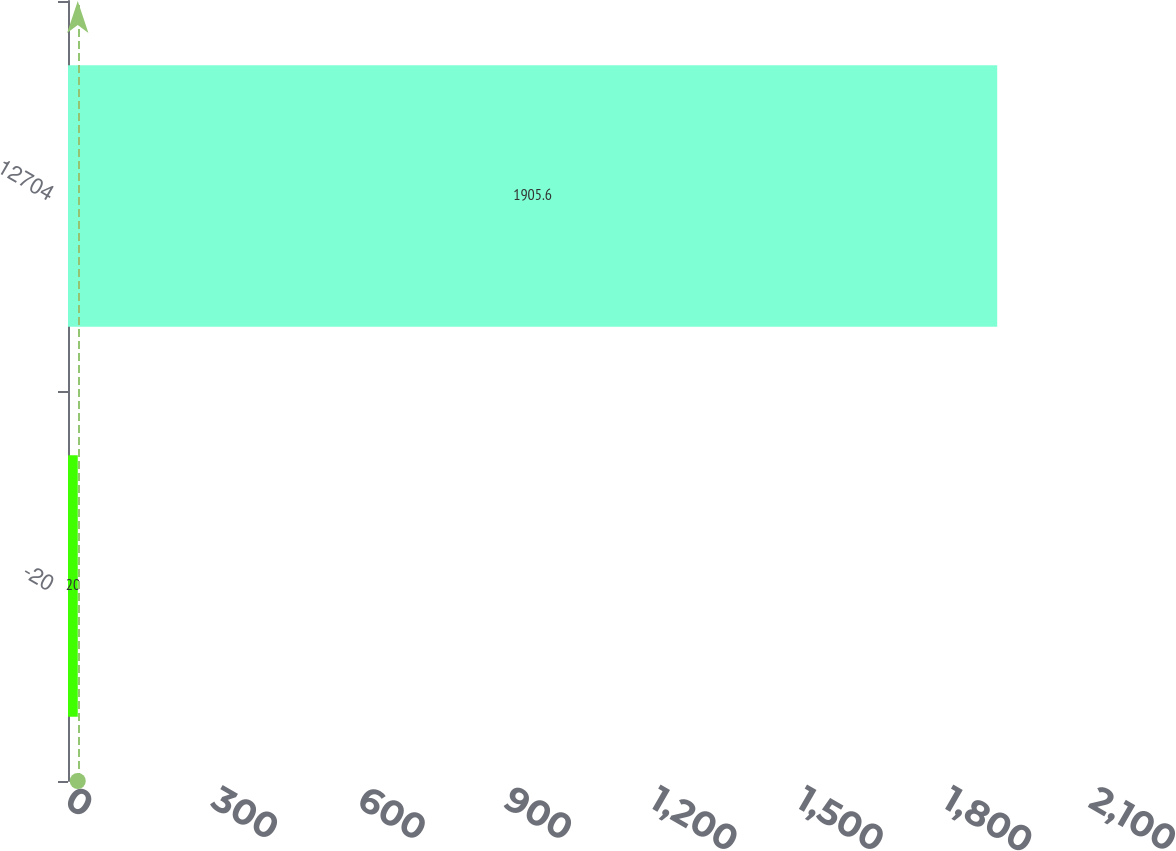Convert chart. <chart><loc_0><loc_0><loc_500><loc_500><bar_chart><fcel>-20<fcel>12704<nl><fcel>20<fcel>1905.6<nl></chart> 